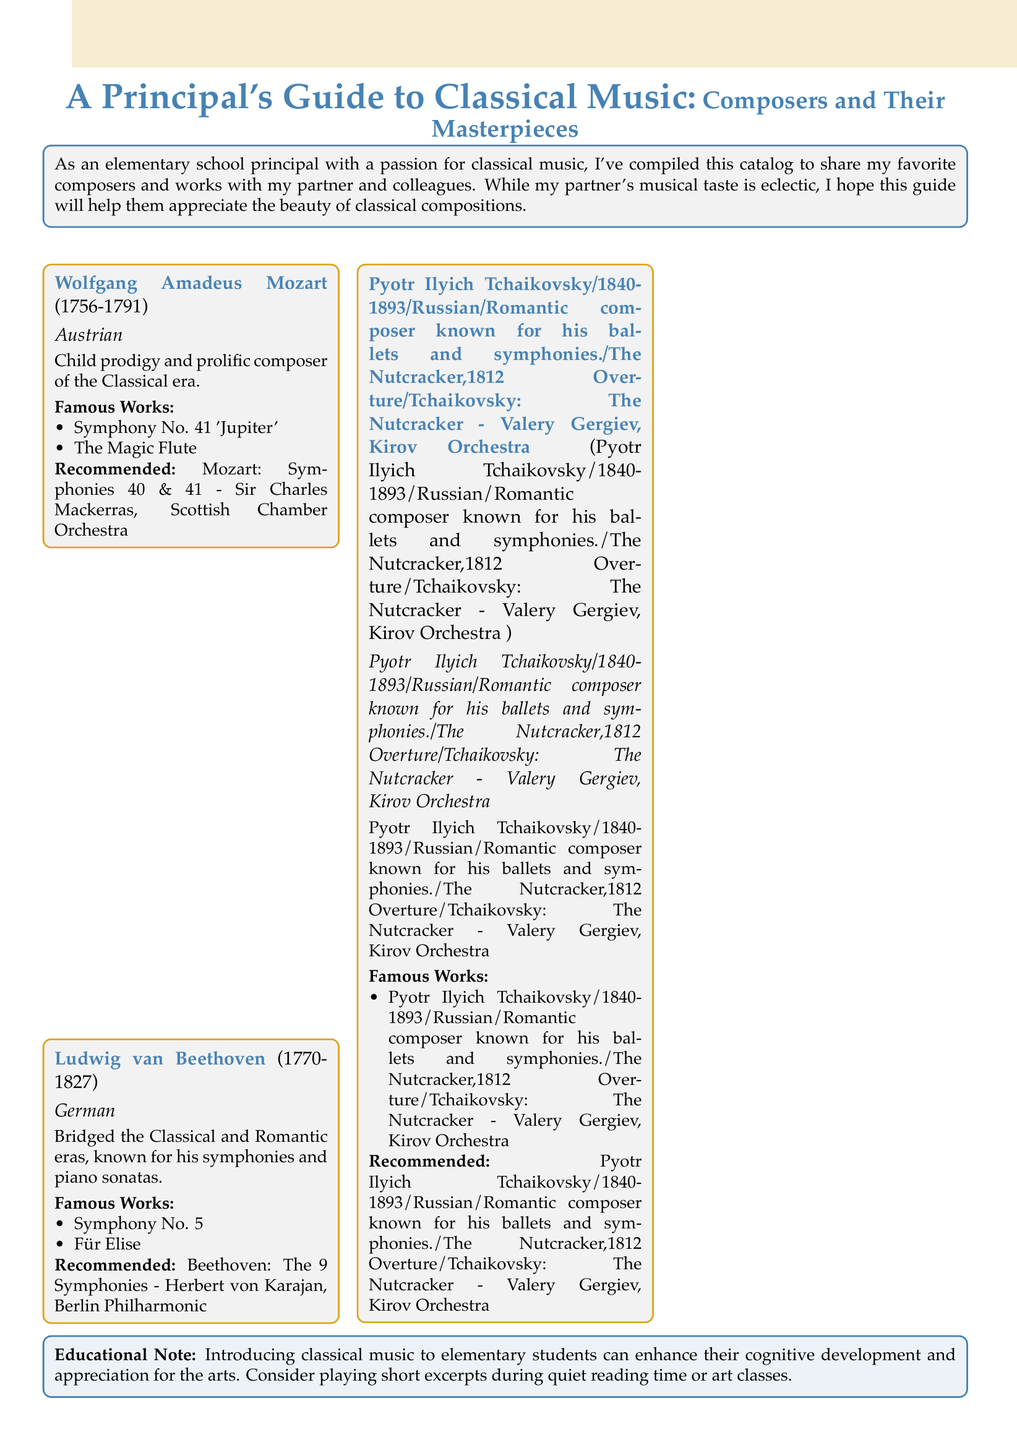What is the nationality of Ludwig van Beethoven? The document specifies Ludwig van Beethoven's nationality as German.
Answer: German Which composer was a child prodigy? The document indicates that Wolfgang Amadeus Mozart was known as a child prodigy.
Answer: Wolfgang Amadeus Mozart What year did Pyotr Ilyich Tchaikovsky die? The document lists Tchaikovsky's lifespan as 1840-1893, so he died in 1893.
Answer: 1893 Name one famous work by Wolfgang Amadeus Mozart. The document lists "Symphony No. 41 'Jupiter'" as one of Mozart's famous works.
Answer: Symphony No. 41 'Jupiter' Who is the conductor for the recommended recording of Tchaikovsky's The Nutcracker? The document states that Valery Gergiev conducted the recommended recording of The Nutcracker.
Answer: Valery Gergiev Which two composers are mentioned in the same era? The document places Beethoven and Mozart in the Classical era.
Answer: Beethoven, Mozart What is the purpose of the 'Educational Note' section? The section emphasizes the benefits of introducing classical music to elementary students for their cognitive development.
Answer: Cognitive development How many composers are featured in this catalog? The document lists three composers: Mozart, Beethoven, and Tchaikovsky.
Answer: Three What is the main theme of the catalog? The catalog focuses on classical music composers and their masterworks for appreciation and education.
Answer: Classical music composers and their masterworks 